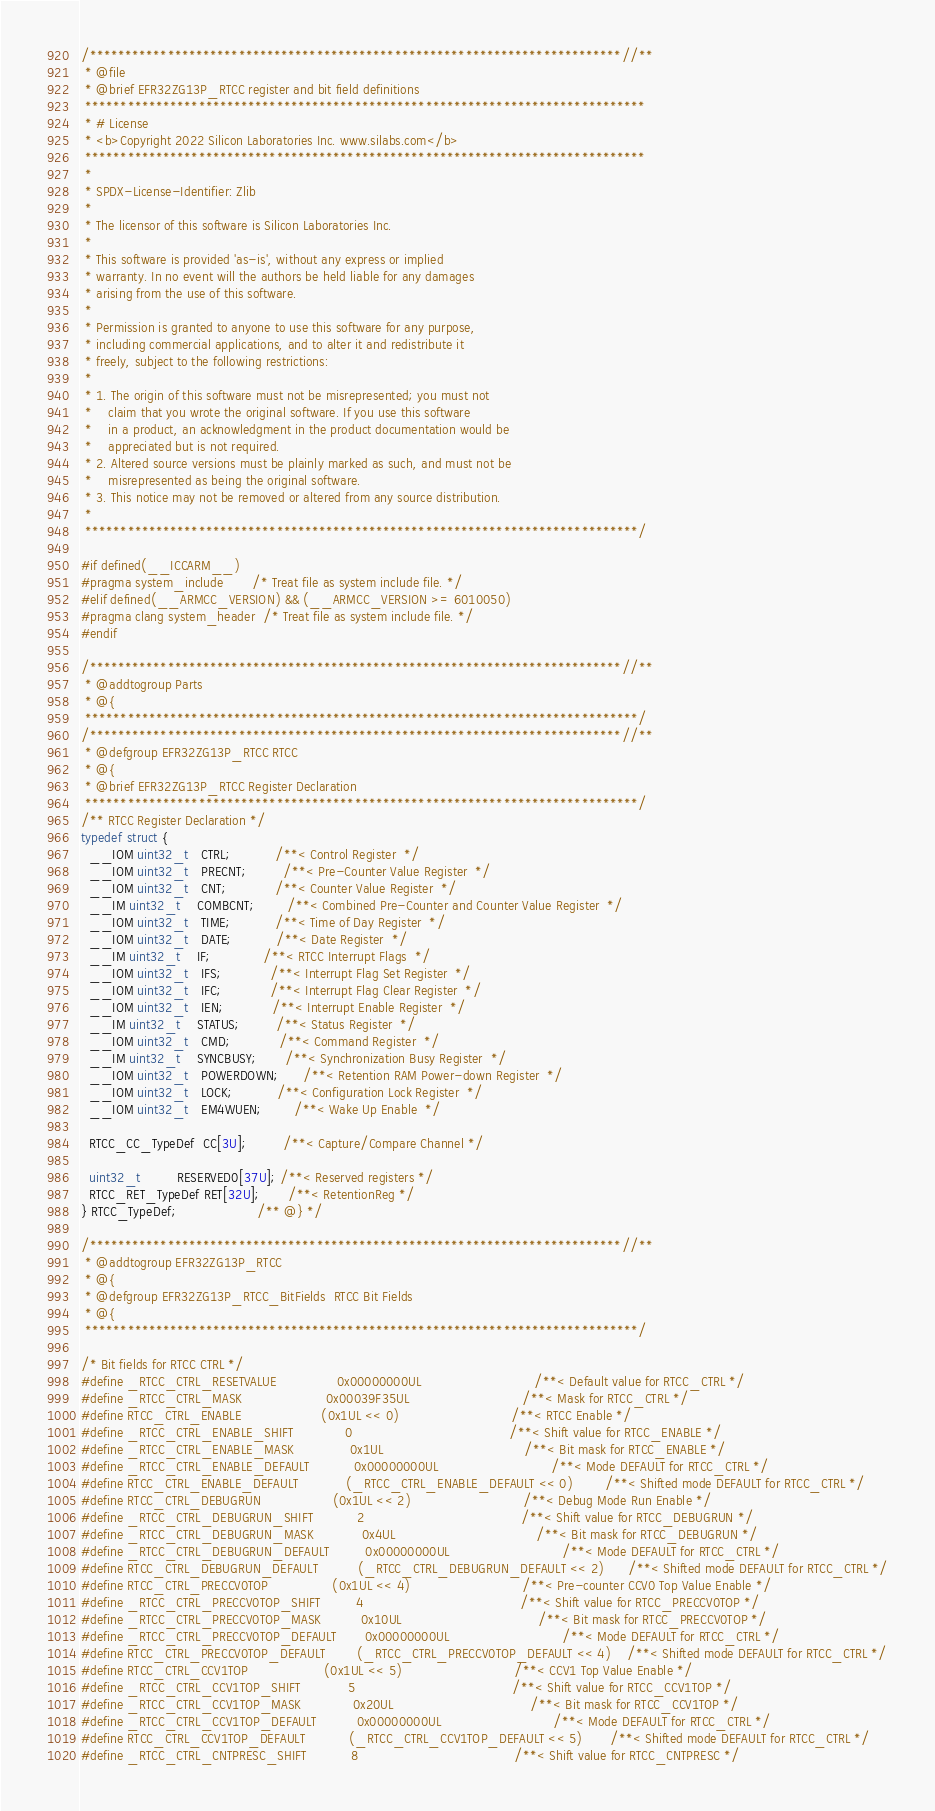Convert code to text. <code><loc_0><loc_0><loc_500><loc_500><_C_>/***************************************************************************//**
 * @file
 * @brief EFR32ZG13P_RTCC register and bit field definitions
 *******************************************************************************
 * # License
 * <b>Copyright 2022 Silicon Laboratories Inc. www.silabs.com</b>
 *******************************************************************************
 *
 * SPDX-License-Identifier: Zlib
 *
 * The licensor of this software is Silicon Laboratories Inc.
 *
 * This software is provided 'as-is', without any express or implied
 * warranty. In no event will the authors be held liable for any damages
 * arising from the use of this software.
 *
 * Permission is granted to anyone to use this software for any purpose,
 * including commercial applications, and to alter it and redistribute it
 * freely, subject to the following restrictions:
 *
 * 1. The origin of this software must not be misrepresented; you must not
 *    claim that you wrote the original software. If you use this software
 *    in a product, an acknowledgment in the product documentation would be
 *    appreciated but is not required.
 * 2. Altered source versions must be plainly marked as such, and must not be
 *    misrepresented as being the original software.
 * 3. This notice may not be removed or altered from any source distribution.
 *
 ******************************************************************************/

#if defined(__ICCARM__)
#pragma system_include       /* Treat file as system include file. */
#elif defined(__ARMCC_VERSION) && (__ARMCC_VERSION >= 6010050)
#pragma clang system_header  /* Treat file as system include file. */
#endif

/***************************************************************************//**
 * @addtogroup Parts
 * @{
 ******************************************************************************/
/***************************************************************************//**
 * @defgroup EFR32ZG13P_RTCC RTCC
 * @{
 * @brief EFR32ZG13P_RTCC Register Declaration
 ******************************************************************************/
/** RTCC Register Declaration */
typedef struct {
  __IOM uint32_t   CTRL;           /**< Control Register  */
  __IOM uint32_t   PRECNT;         /**< Pre-Counter Value Register  */
  __IOM uint32_t   CNT;            /**< Counter Value Register  */
  __IM uint32_t    COMBCNT;        /**< Combined Pre-Counter and Counter Value Register  */
  __IOM uint32_t   TIME;           /**< Time of Day Register  */
  __IOM uint32_t   DATE;           /**< Date Register  */
  __IM uint32_t    IF;             /**< RTCC Interrupt Flags  */
  __IOM uint32_t   IFS;            /**< Interrupt Flag Set Register  */
  __IOM uint32_t   IFC;            /**< Interrupt Flag Clear Register  */
  __IOM uint32_t   IEN;            /**< Interrupt Enable Register  */
  __IM uint32_t    STATUS;         /**< Status Register  */
  __IOM uint32_t   CMD;            /**< Command Register  */
  __IM uint32_t    SYNCBUSY;       /**< Synchronization Busy Register  */
  __IOM uint32_t   POWERDOWN;      /**< Retention RAM Power-down Register  */
  __IOM uint32_t   LOCK;           /**< Configuration Lock Register  */
  __IOM uint32_t   EM4WUEN;        /**< Wake Up Enable  */

  RTCC_CC_TypeDef  CC[3U];         /**< Capture/Compare Channel */

  uint32_t         RESERVED0[37U]; /**< Reserved registers */
  RTCC_RET_TypeDef RET[32U];       /**< RetentionReg */
} RTCC_TypeDef;                    /** @} */

/***************************************************************************//**
 * @addtogroup EFR32ZG13P_RTCC
 * @{
 * @defgroup EFR32ZG13P_RTCC_BitFields  RTCC Bit Fields
 * @{
 ******************************************************************************/

/* Bit fields for RTCC CTRL */
#define _RTCC_CTRL_RESETVALUE               0x00000000UL                            /**< Default value for RTCC_CTRL */
#define _RTCC_CTRL_MASK                     0x00039F35UL                            /**< Mask for RTCC_CTRL */
#define RTCC_CTRL_ENABLE                    (0x1UL << 0)                            /**< RTCC Enable */
#define _RTCC_CTRL_ENABLE_SHIFT             0                                       /**< Shift value for RTCC_ENABLE */
#define _RTCC_CTRL_ENABLE_MASK              0x1UL                                   /**< Bit mask for RTCC_ENABLE */
#define _RTCC_CTRL_ENABLE_DEFAULT           0x00000000UL                            /**< Mode DEFAULT for RTCC_CTRL */
#define RTCC_CTRL_ENABLE_DEFAULT            (_RTCC_CTRL_ENABLE_DEFAULT << 0)        /**< Shifted mode DEFAULT for RTCC_CTRL */
#define RTCC_CTRL_DEBUGRUN                  (0x1UL << 2)                            /**< Debug Mode Run Enable */
#define _RTCC_CTRL_DEBUGRUN_SHIFT           2                                       /**< Shift value for RTCC_DEBUGRUN */
#define _RTCC_CTRL_DEBUGRUN_MASK            0x4UL                                   /**< Bit mask for RTCC_DEBUGRUN */
#define _RTCC_CTRL_DEBUGRUN_DEFAULT         0x00000000UL                            /**< Mode DEFAULT for RTCC_CTRL */
#define RTCC_CTRL_DEBUGRUN_DEFAULT          (_RTCC_CTRL_DEBUGRUN_DEFAULT << 2)      /**< Shifted mode DEFAULT for RTCC_CTRL */
#define RTCC_CTRL_PRECCV0TOP                (0x1UL << 4)                            /**< Pre-counter CCV0 Top Value Enable */
#define _RTCC_CTRL_PRECCV0TOP_SHIFT         4                                       /**< Shift value for RTCC_PRECCV0TOP */
#define _RTCC_CTRL_PRECCV0TOP_MASK          0x10UL                                  /**< Bit mask for RTCC_PRECCV0TOP */
#define _RTCC_CTRL_PRECCV0TOP_DEFAULT       0x00000000UL                            /**< Mode DEFAULT for RTCC_CTRL */
#define RTCC_CTRL_PRECCV0TOP_DEFAULT        (_RTCC_CTRL_PRECCV0TOP_DEFAULT << 4)    /**< Shifted mode DEFAULT for RTCC_CTRL */
#define RTCC_CTRL_CCV1TOP                   (0x1UL << 5)                            /**< CCV1 Top Value Enable */
#define _RTCC_CTRL_CCV1TOP_SHIFT            5                                       /**< Shift value for RTCC_CCV1TOP */
#define _RTCC_CTRL_CCV1TOP_MASK             0x20UL                                  /**< Bit mask for RTCC_CCV1TOP */
#define _RTCC_CTRL_CCV1TOP_DEFAULT          0x00000000UL                            /**< Mode DEFAULT for RTCC_CTRL */
#define RTCC_CTRL_CCV1TOP_DEFAULT           (_RTCC_CTRL_CCV1TOP_DEFAULT << 5)       /**< Shifted mode DEFAULT for RTCC_CTRL */
#define _RTCC_CTRL_CNTPRESC_SHIFT           8                                       /**< Shift value for RTCC_CNTPRESC */</code> 